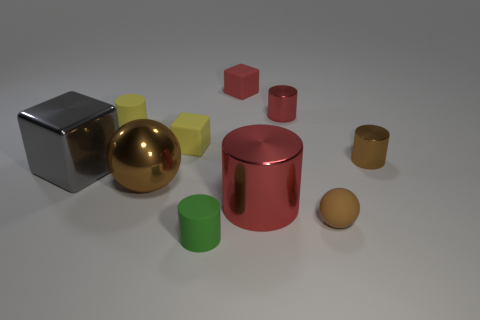Subtract all large gray shiny cubes. How many cubes are left? 2 Subtract all balls. How many objects are left? 8 Subtract all red cylinders. How many cylinders are left? 3 Subtract 0 purple balls. How many objects are left? 10 Subtract 1 balls. How many balls are left? 1 Subtract all brown cubes. Subtract all green balls. How many cubes are left? 3 Subtract all yellow balls. How many green cylinders are left? 1 Subtract all large cylinders. Subtract all tiny blocks. How many objects are left? 7 Add 2 tiny yellow matte cylinders. How many tiny yellow matte cylinders are left? 3 Add 2 shiny spheres. How many shiny spheres exist? 3 